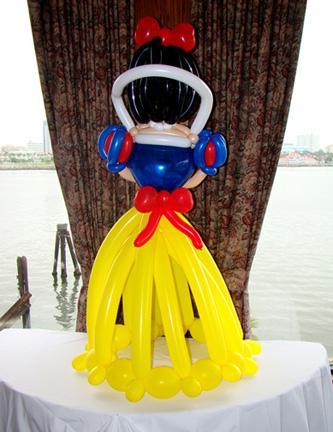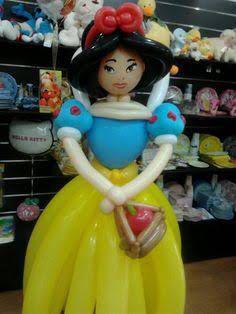The first image is the image on the left, the second image is the image on the right. Given the left and right images, does the statement "There are two princess balloon figures looking forward." hold true? Answer yes or no. No. The first image is the image on the left, the second image is the image on the right. Evaluate the accuracy of this statement regarding the images: "Four faces are visible.". Is it true? Answer yes or no. No. 